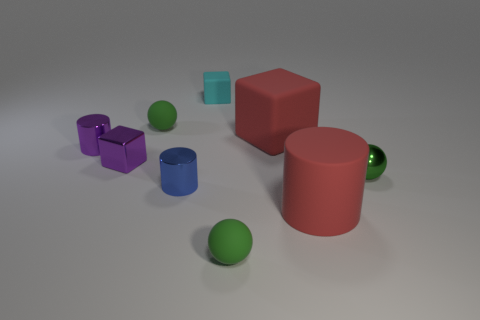Does the tiny green metallic object have the same shape as the tiny blue thing?
Provide a succinct answer. No. There is a green sphere on the left side of the small cyan matte cube that is behind the small blue metallic cylinder; are there any cyan rubber objects in front of it?
Provide a short and direct response. No. How many cylinders have the same color as the shiny cube?
Your answer should be very brief. 1. What is the shape of the green shiny thing that is the same size as the purple metal cube?
Make the answer very short. Sphere. Are there any matte balls behind the small cyan matte block?
Give a very brief answer. No. Is the cyan matte cube the same size as the green metallic sphere?
Offer a terse response. Yes. The small green thing that is to the left of the tiny cyan object has what shape?
Provide a succinct answer. Sphere. Are there any red cylinders of the same size as the red block?
Keep it short and to the point. Yes. What is the material of the red object that is the same size as the matte cylinder?
Your answer should be compact. Rubber. There is a cylinder in front of the blue metallic cylinder; how big is it?
Your answer should be very brief. Large. 